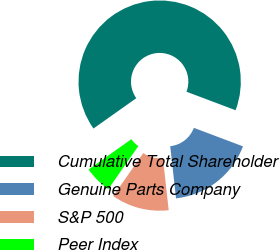Convert chart. <chart><loc_0><loc_0><loc_500><loc_500><pie_chart><fcel>Cumulative Total Shareholder<fcel>Genuine Parts Company<fcel>S&P 500<fcel>Peer Index<nl><fcel>65.55%<fcel>17.49%<fcel>11.48%<fcel>5.48%<nl></chart> 